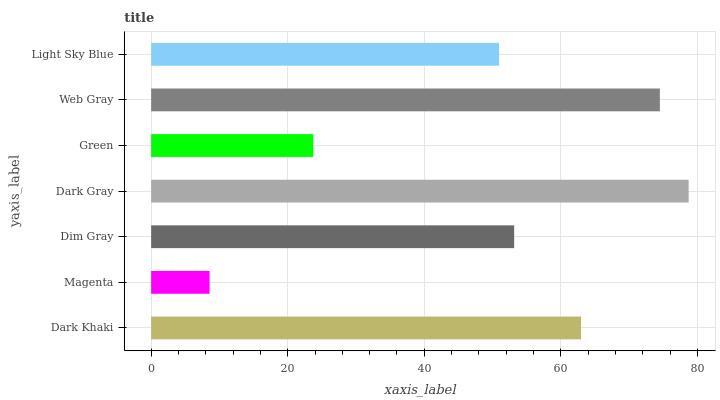Is Magenta the minimum?
Answer yes or no. Yes. Is Dark Gray the maximum?
Answer yes or no. Yes. Is Dim Gray the minimum?
Answer yes or no. No. Is Dim Gray the maximum?
Answer yes or no. No. Is Dim Gray greater than Magenta?
Answer yes or no. Yes. Is Magenta less than Dim Gray?
Answer yes or no. Yes. Is Magenta greater than Dim Gray?
Answer yes or no. No. Is Dim Gray less than Magenta?
Answer yes or no. No. Is Dim Gray the high median?
Answer yes or no. Yes. Is Dim Gray the low median?
Answer yes or no. Yes. Is Dark Gray the high median?
Answer yes or no. No. Is Web Gray the low median?
Answer yes or no. No. 